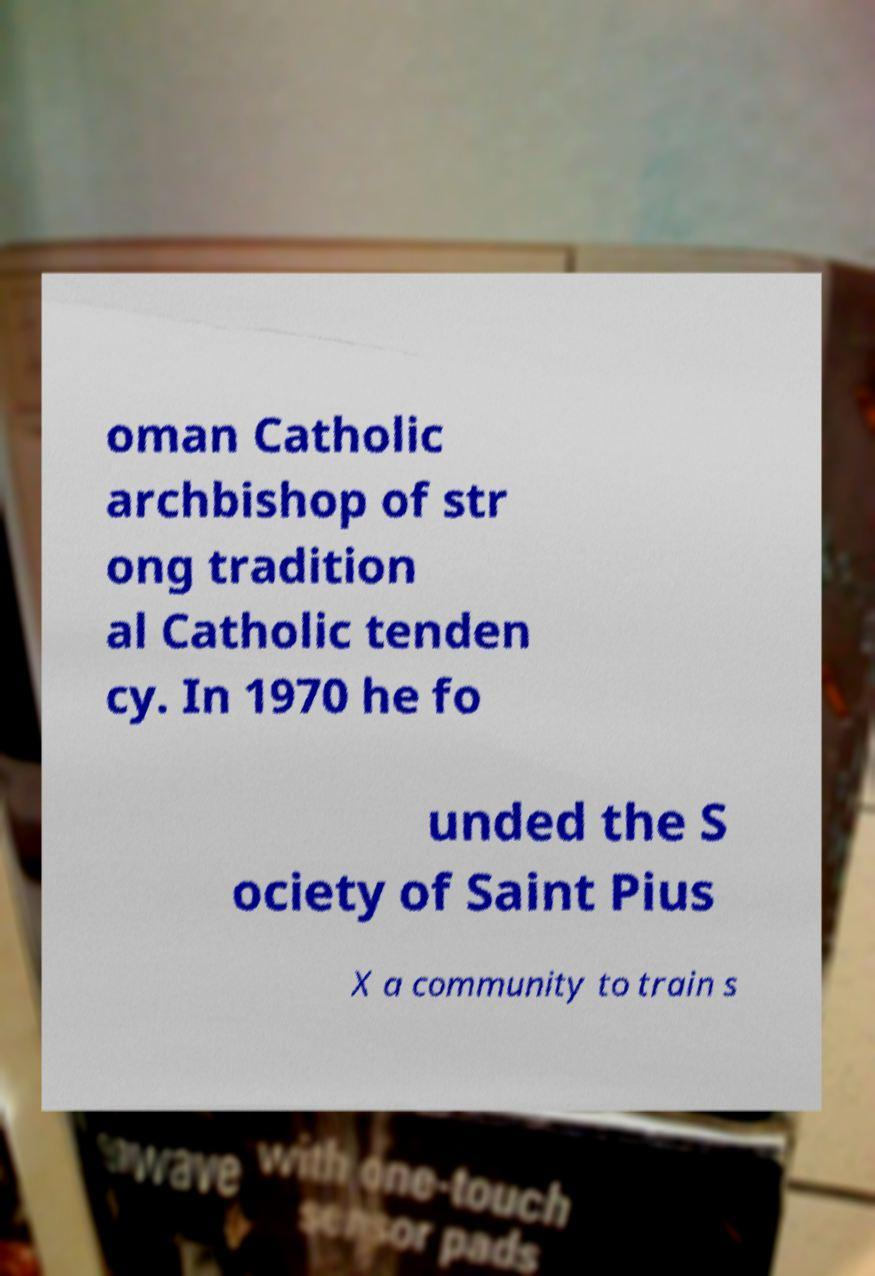Could you extract and type out the text from this image? oman Catholic archbishop of str ong tradition al Catholic tenden cy. In 1970 he fo unded the S ociety of Saint Pius X a community to train s 